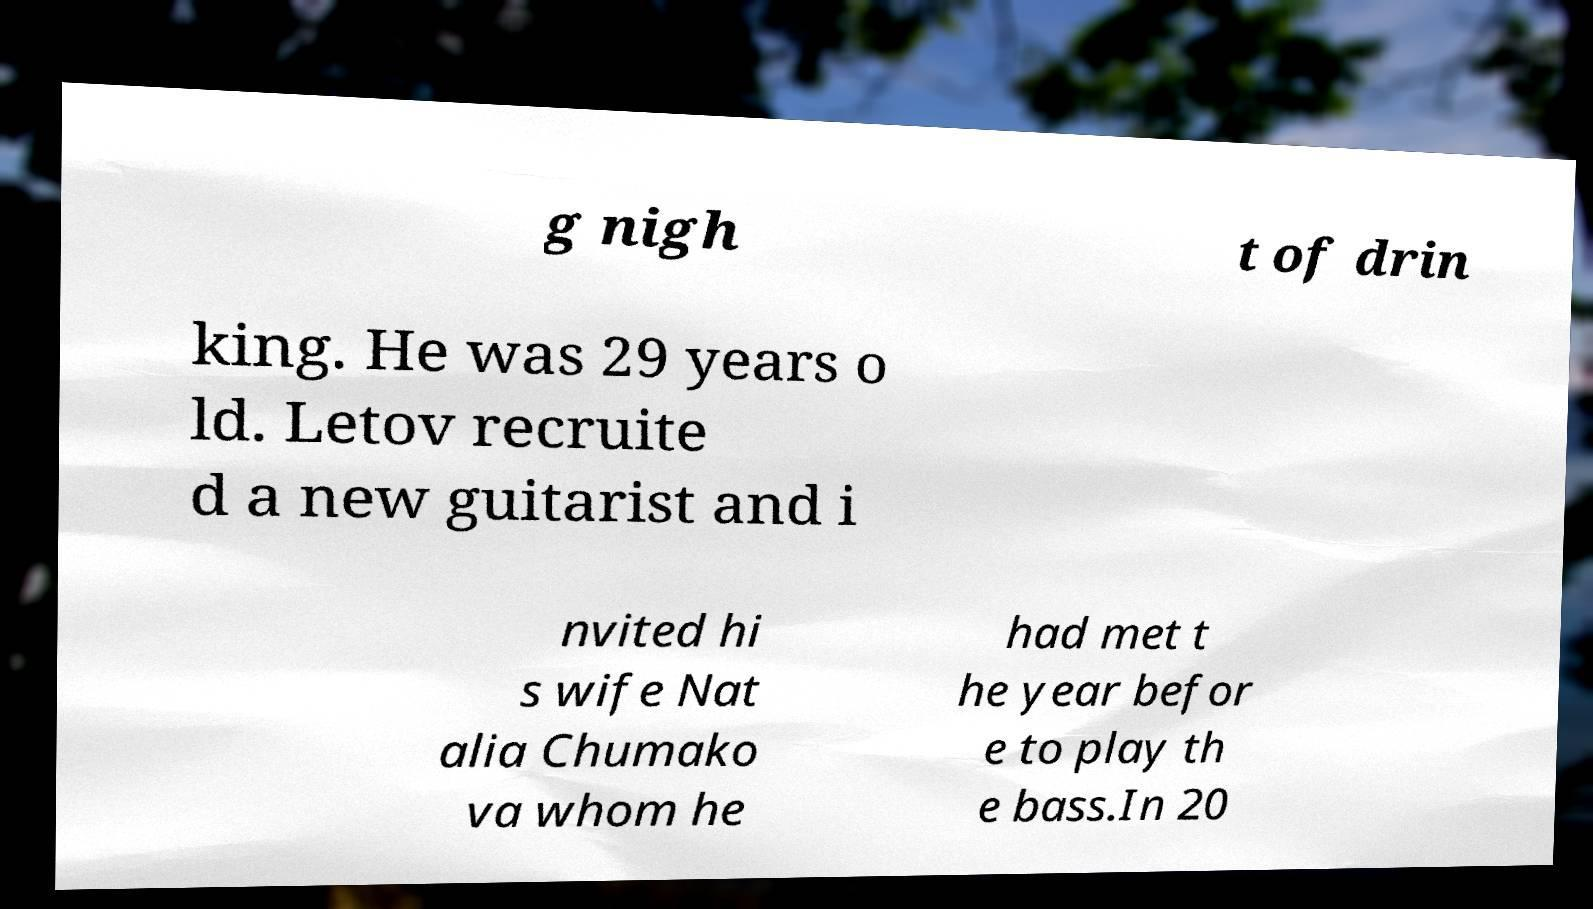Can you accurately transcribe the text from the provided image for me? g nigh t of drin king. He was 29 years o ld. Letov recruite d a new guitarist and i nvited hi s wife Nat alia Chumako va whom he had met t he year befor e to play th e bass.In 20 